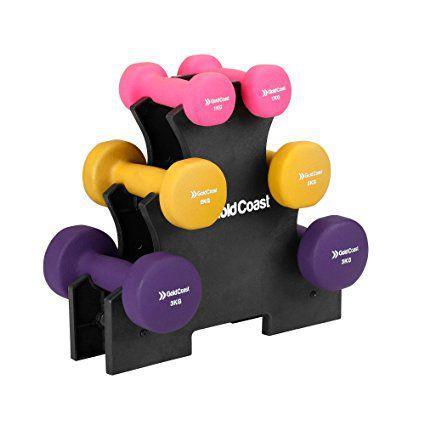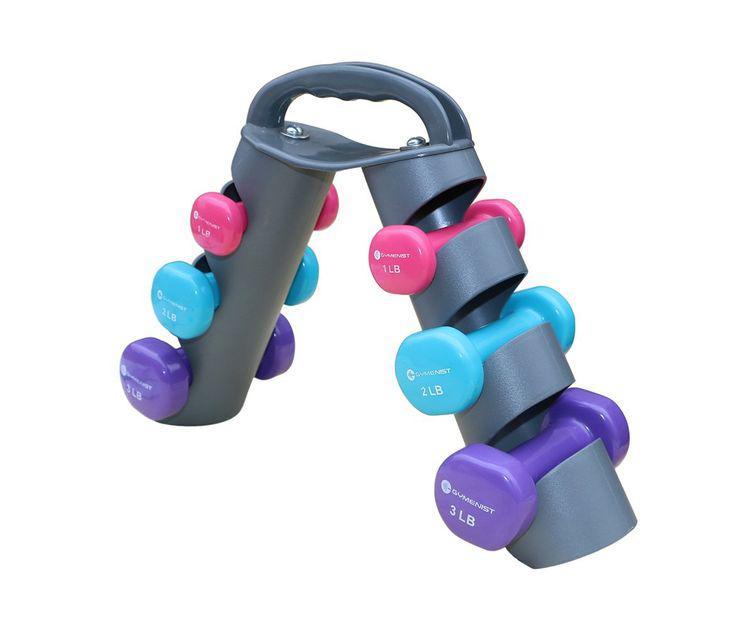The first image is the image on the left, the second image is the image on the right. Evaluate the accuracy of this statement regarding the images: "A lavender weight is at the top of the holder in one of the images.". Is it true? Answer yes or no. No. The first image is the image on the left, the second image is the image on the right. Given the left and right images, does the statement "In each image, three pairs of dumbbells, each a different color, at stacked on a triangular shaped rack with a pink pair in the uppermost position." hold true? Answer yes or no. Yes. 